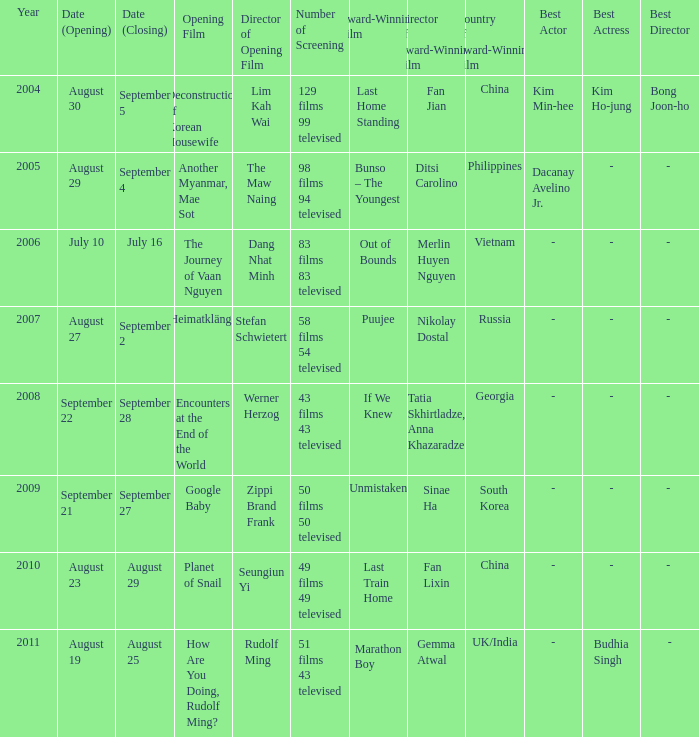What is the number of times the opening film, the journey of vaan nguyen, was screened? 1.0. 